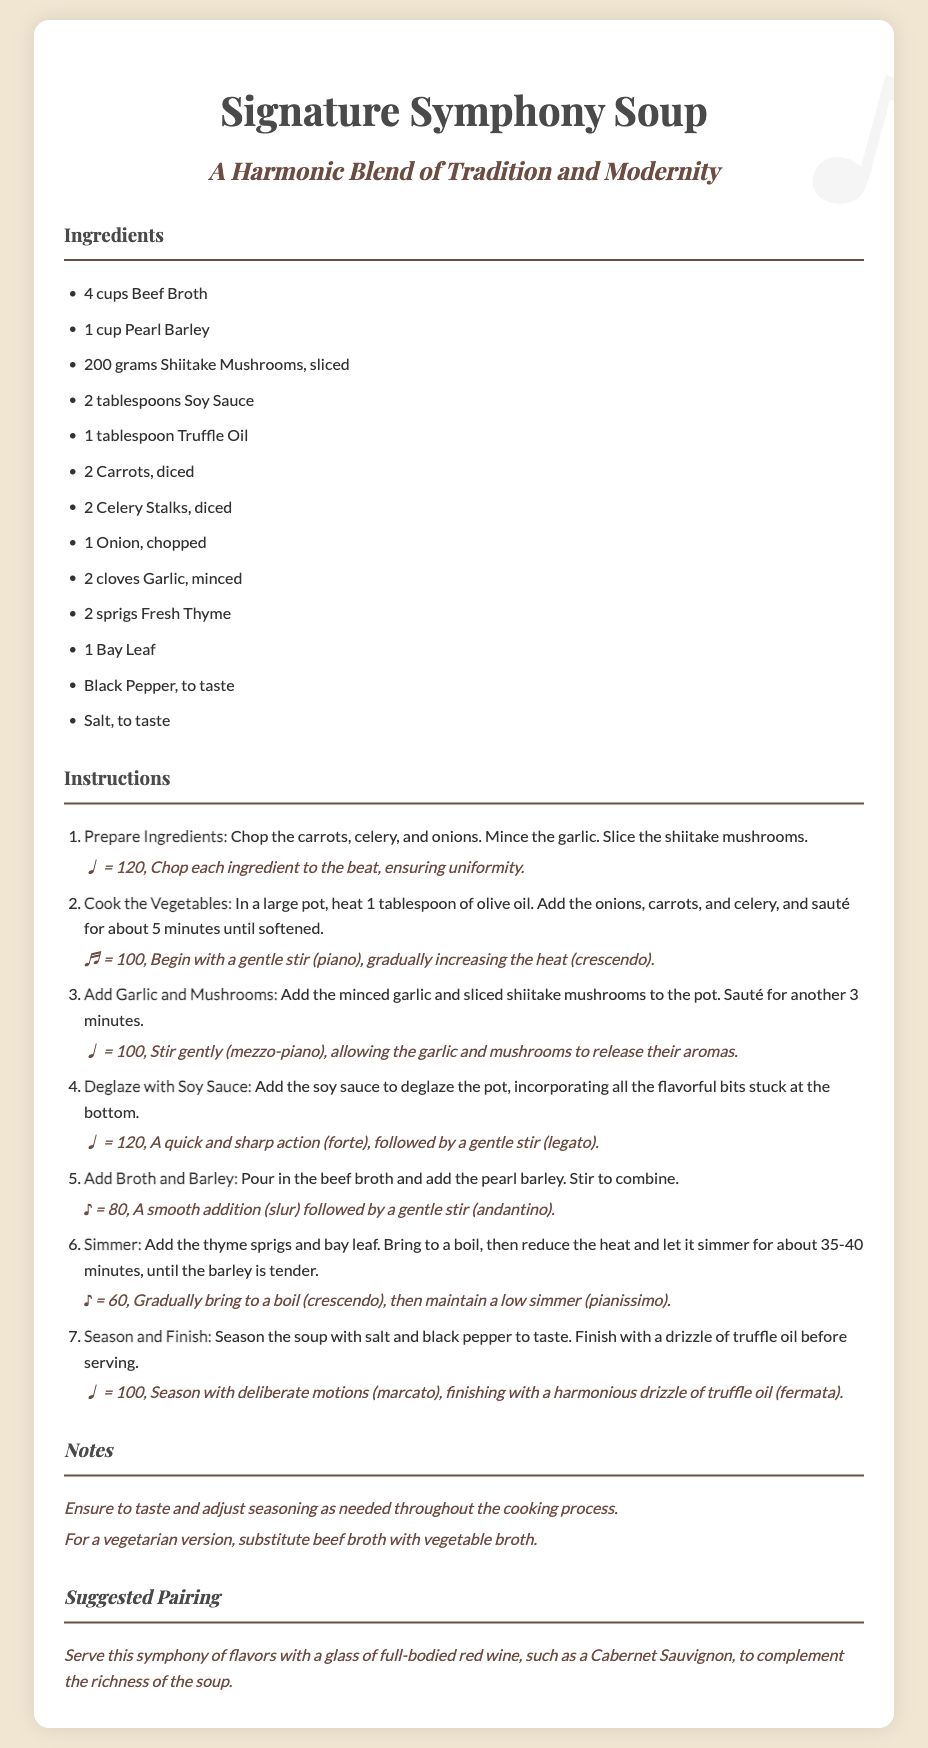what are the key ingredients in the soup? The ingredients listed in the document include beef broth, pearl barley, shiitake mushrooms, soy sauce, truffle oil, carrots, celery, onion, garlic, thyme, bay leaf, black pepper, and salt.
Answer: beef broth, pearl barley, shiitake mushrooms, soy sauce, truffle oil, carrots, celery, onion, garlic, thyme, bay leaf, black pepper, salt how long should you simmer the soup? The document states the soup should be simmered for about 35-40 minutes.
Answer: 35-40 minutes what is the main cooking method for the vegetables? The instructions indicate that the main cooking method for the vegetables is sautéing.
Answer: sautéing what is an alternative ingredient for a vegetarian version? The document suggests that vegetable broth can be used as a substitute for beef broth in a vegetarian version.
Answer: vegetable broth what wine is suggested to pair with the soup? The document recommends pairing the soup with a glass of full-bodied red wine, specifically Cabernet Sauvignon.
Answer: Cabernet Sauvignon 